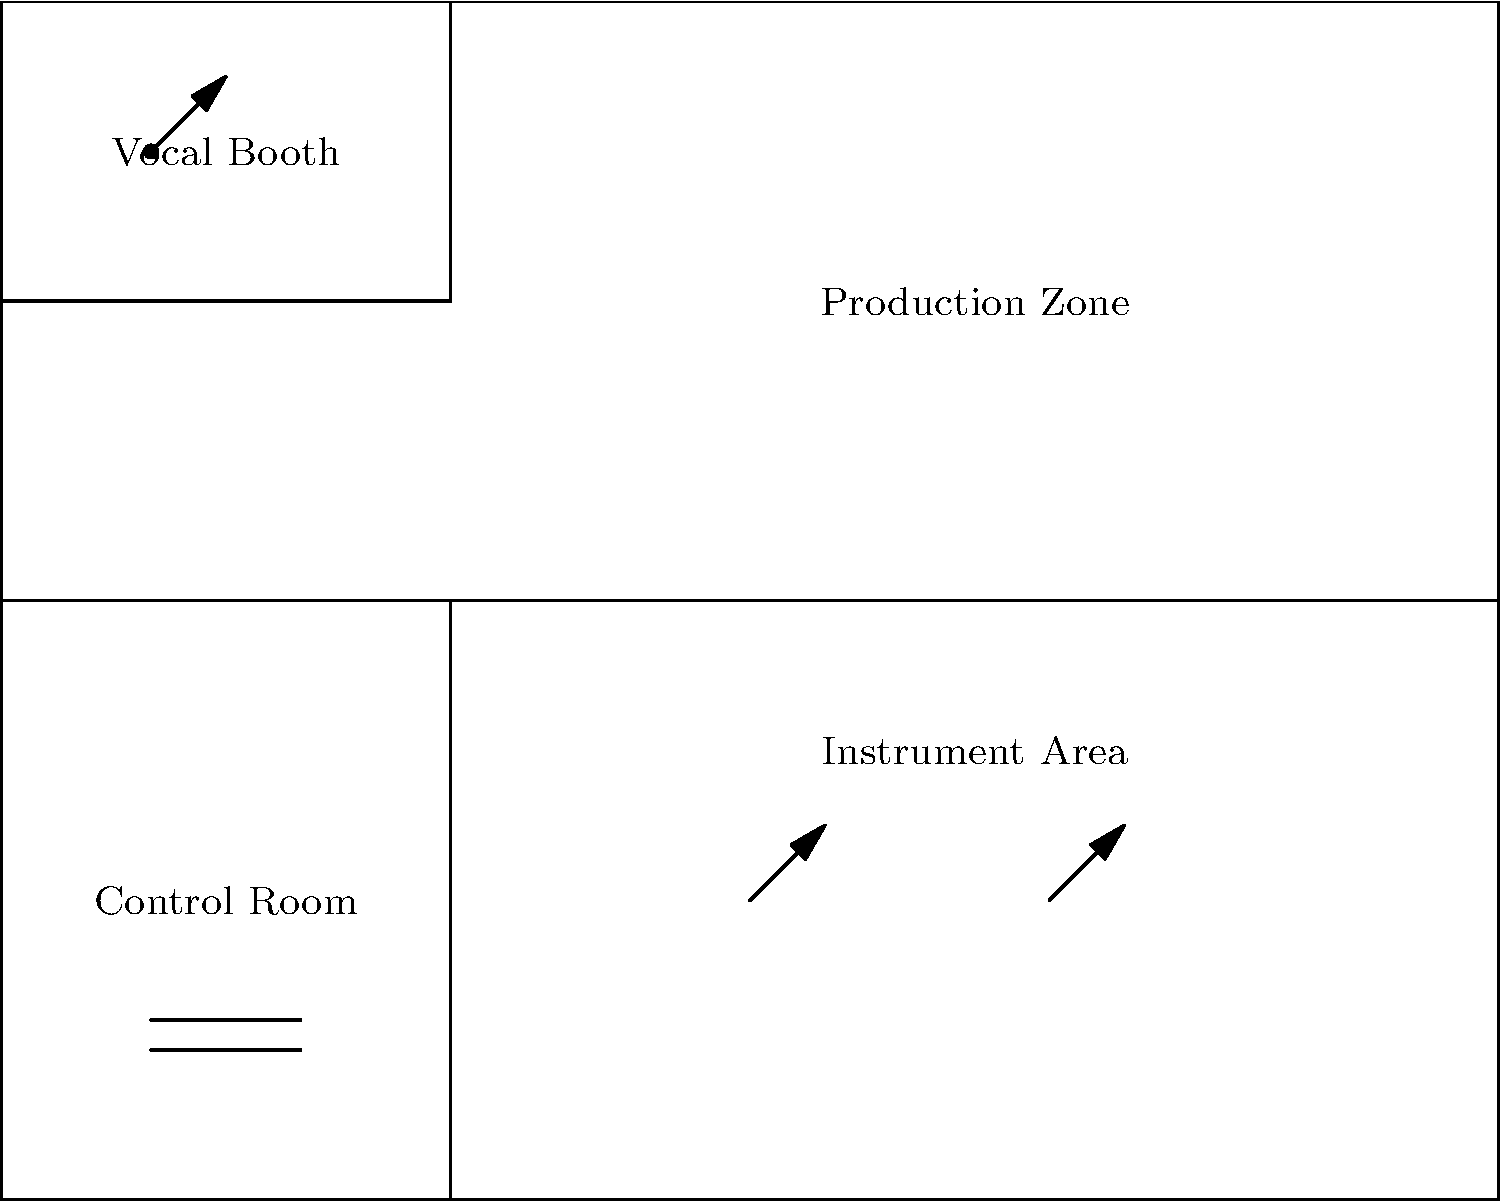In the recording studio layout shown, which area is strategically positioned to have direct visual contact with both the vocal booth and instrument area, allowing for efficient communication and coordination during recording sessions? To answer this question, let's analyze the layout of the recording studio:

1. The studio is divided into four main areas: Vocal Booth, Instrument Area, Control Room, and Production Zone.

2. The Vocal Booth is located in the upper-left corner of the studio, providing isolation for vocal recordings.

3. The Instrument Area occupies the lower half of the studio, giving ample space for various instruments and performers.

4. The Control Room is positioned in the lower-left corner of the studio.

5. The Production Zone takes up the remaining space in the upper-right portion of the studio.

6. The Control Room is strategically placed between the Vocal Booth and the Instrument Area.

7. This positioning allows the sound engineer or producer in the Control Room to have direct visual contact with both the vocalist in the Vocal Booth and the musicians in the Instrument Area.

8. The central location of the Control Room facilitates easy communication and coordination between all areas of the studio during recording sessions.

Therefore, the Control Room is the area that is strategically positioned to have direct visual contact with both the vocal booth and instrument area, allowing for efficient communication and coordination during recording sessions.
Answer: Control Room 